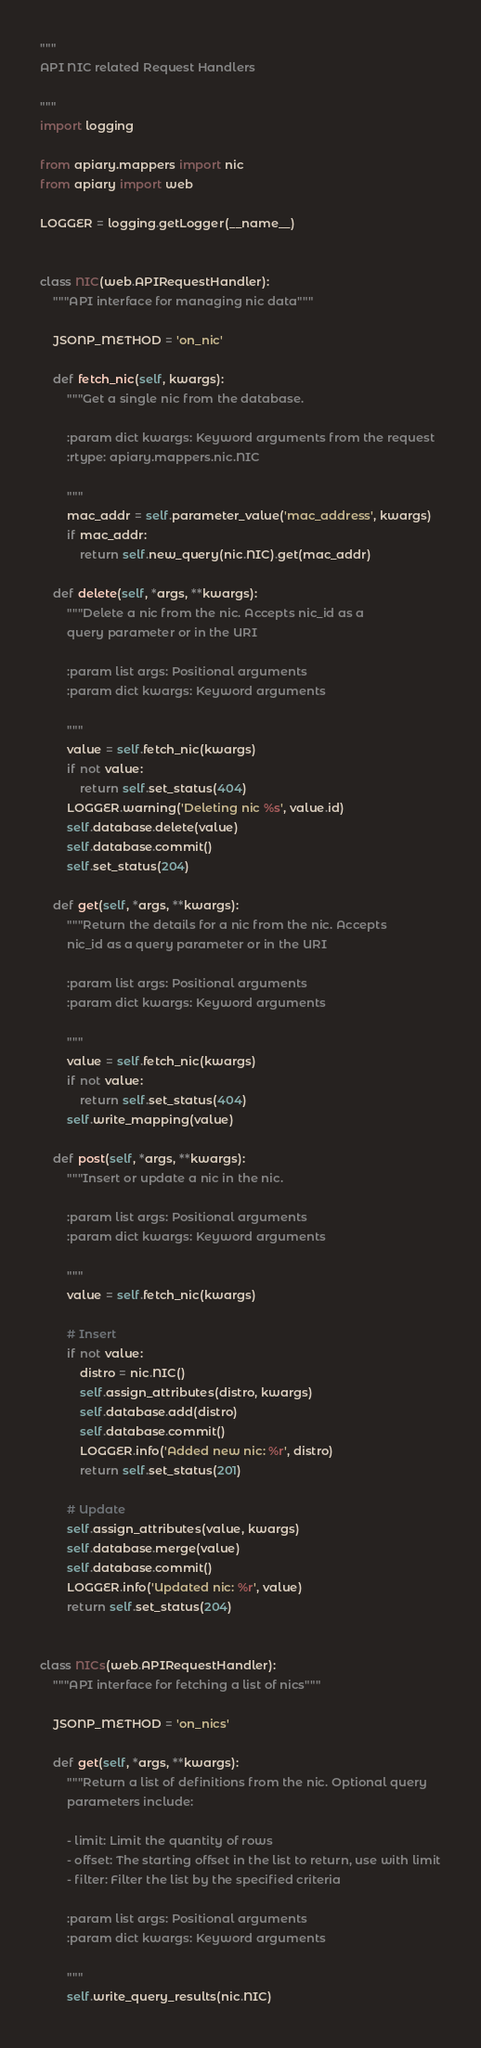<code> <loc_0><loc_0><loc_500><loc_500><_Python_>"""
API NIC related Request Handlers

"""
import logging

from apiary.mappers import nic
from apiary import web

LOGGER = logging.getLogger(__name__)


class NIC(web.APIRequestHandler):
    """API interface for managing nic data"""

    JSONP_METHOD = 'on_nic'

    def fetch_nic(self, kwargs):
        """Get a single nic from the database.

        :param dict kwargs: Keyword arguments from the request
        :rtype: apiary.mappers.nic.NIC

        """
        mac_addr = self.parameter_value('mac_address', kwargs)
        if mac_addr:
            return self.new_query(nic.NIC).get(mac_addr)

    def delete(self, *args, **kwargs):
        """Delete a nic from the nic. Accepts nic_id as a
        query parameter or in the URI

        :param list args: Positional arguments
        :param dict kwargs: Keyword arguments

        """
        value = self.fetch_nic(kwargs)
        if not value:
            return self.set_status(404)
        LOGGER.warning('Deleting nic %s', value.id)
        self.database.delete(value)
        self.database.commit()
        self.set_status(204)

    def get(self, *args, **kwargs):
        """Return the details for a nic from the nic. Accepts
        nic_id as a query parameter or in the URI

        :param list args: Positional arguments
        :param dict kwargs: Keyword arguments

        """
        value = self.fetch_nic(kwargs)
        if not value:
            return self.set_status(404)
        self.write_mapping(value)

    def post(self, *args, **kwargs):
        """Insert or update a nic in the nic.

        :param list args: Positional arguments
        :param dict kwargs: Keyword arguments

        """
        value = self.fetch_nic(kwargs)

        # Insert
        if not value:
            distro = nic.NIC()
            self.assign_attributes(distro, kwargs)
            self.database.add(distro)
            self.database.commit()
            LOGGER.info('Added new nic: %r', distro)
            return self.set_status(201)

        # Update
        self.assign_attributes(value, kwargs)
        self.database.merge(value)
        self.database.commit()
        LOGGER.info('Updated nic: %r', value)
        return self.set_status(204)


class NICs(web.APIRequestHandler):
    """API interface for fetching a list of nics"""

    JSONP_METHOD = 'on_nics'

    def get(self, *args, **kwargs):
        """Return a list of definitions from the nic. Optional query
        parameters include:

        - limit: Limit the quantity of rows
        - offset: The starting offset in the list to return, use with limit
        - filter: Filter the list by the specified criteria

        :param list args: Positional arguments
        :param dict kwargs: Keyword arguments

        """
        self.write_query_results(nic.NIC)
</code> 